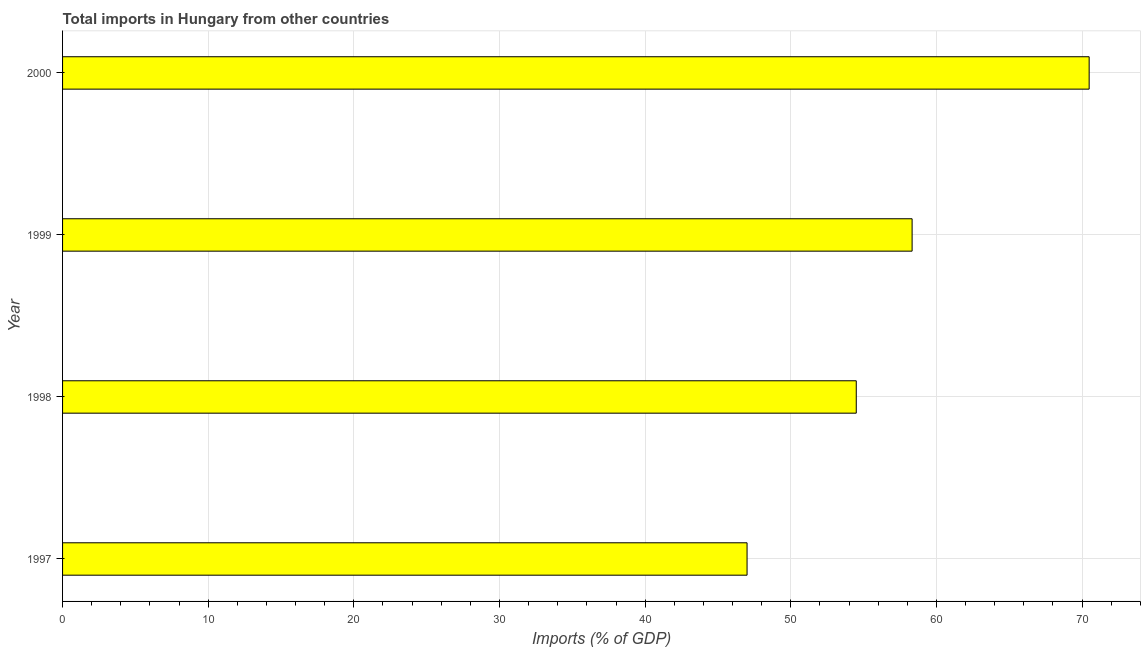Does the graph contain any zero values?
Your answer should be very brief. No. What is the title of the graph?
Offer a very short reply. Total imports in Hungary from other countries. What is the label or title of the X-axis?
Ensure brevity in your answer.  Imports (% of GDP). What is the label or title of the Y-axis?
Keep it short and to the point. Year. What is the total imports in 2000?
Your answer should be very brief. 70.49. Across all years, what is the maximum total imports?
Ensure brevity in your answer.  70.49. Across all years, what is the minimum total imports?
Keep it short and to the point. 47. In which year was the total imports maximum?
Ensure brevity in your answer.  2000. What is the sum of the total imports?
Offer a very short reply. 230.31. What is the difference between the total imports in 1997 and 1998?
Give a very brief answer. -7.5. What is the average total imports per year?
Offer a terse response. 57.58. What is the median total imports?
Your response must be concise. 56.41. In how many years, is the total imports greater than 26 %?
Keep it short and to the point. 4. Do a majority of the years between 1999 and 1997 (inclusive) have total imports greater than 48 %?
Your response must be concise. Yes. What is the ratio of the total imports in 1997 to that in 2000?
Your response must be concise. 0.67. Is the difference between the total imports in 1998 and 2000 greater than the difference between any two years?
Keep it short and to the point. No. What is the difference between the highest and the second highest total imports?
Your answer should be compact. 12.16. Is the sum of the total imports in 1998 and 1999 greater than the maximum total imports across all years?
Provide a succinct answer. Yes. What is the difference between the highest and the lowest total imports?
Your response must be concise. 23.49. Are all the bars in the graph horizontal?
Your response must be concise. Yes. How many years are there in the graph?
Your answer should be very brief. 4. What is the difference between two consecutive major ticks on the X-axis?
Provide a succinct answer. 10. What is the Imports (% of GDP) in 1997?
Offer a very short reply. 47. What is the Imports (% of GDP) in 1998?
Provide a short and direct response. 54.5. What is the Imports (% of GDP) in 1999?
Your answer should be very brief. 58.33. What is the Imports (% of GDP) in 2000?
Keep it short and to the point. 70.49. What is the difference between the Imports (% of GDP) in 1997 and 1998?
Keep it short and to the point. -7.5. What is the difference between the Imports (% of GDP) in 1997 and 1999?
Keep it short and to the point. -11.33. What is the difference between the Imports (% of GDP) in 1997 and 2000?
Offer a terse response. -23.49. What is the difference between the Imports (% of GDP) in 1998 and 1999?
Keep it short and to the point. -3.83. What is the difference between the Imports (% of GDP) in 1998 and 2000?
Make the answer very short. -15.99. What is the difference between the Imports (% of GDP) in 1999 and 2000?
Provide a succinct answer. -12.16. What is the ratio of the Imports (% of GDP) in 1997 to that in 1998?
Make the answer very short. 0.86. What is the ratio of the Imports (% of GDP) in 1997 to that in 1999?
Give a very brief answer. 0.81. What is the ratio of the Imports (% of GDP) in 1997 to that in 2000?
Ensure brevity in your answer.  0.67. What is the ratio of the Imports (% of GDP) in 1998 to that in 1999?
Keep it short and to the point. 0.93. What is the ratio of the Imports (% of GDP) in 1998 to that in 2000?
Provide a short and direct response. 0.77. What is the ratio of the Imports (% of GDP) in 1999 to that in 2000?
Offer a very short reply. 0.83. 